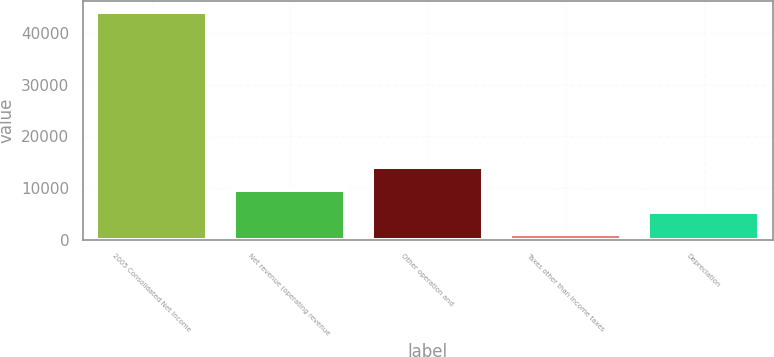Convert chart to OTSL. <chart><loc_0><loc_0><loc_500><loc_500><bar_chart><fcel>2005 Consolidated Net Income<fcel>Net revenue (operating revenue<fcel>Other operation and<fcel>Taxes other than income taxes<fcel>Depreciation<nl><fcel>44052<fcel>9699.2<fcel>13993.3<fcel>1111<fcel>5405.1<nl></chart> 